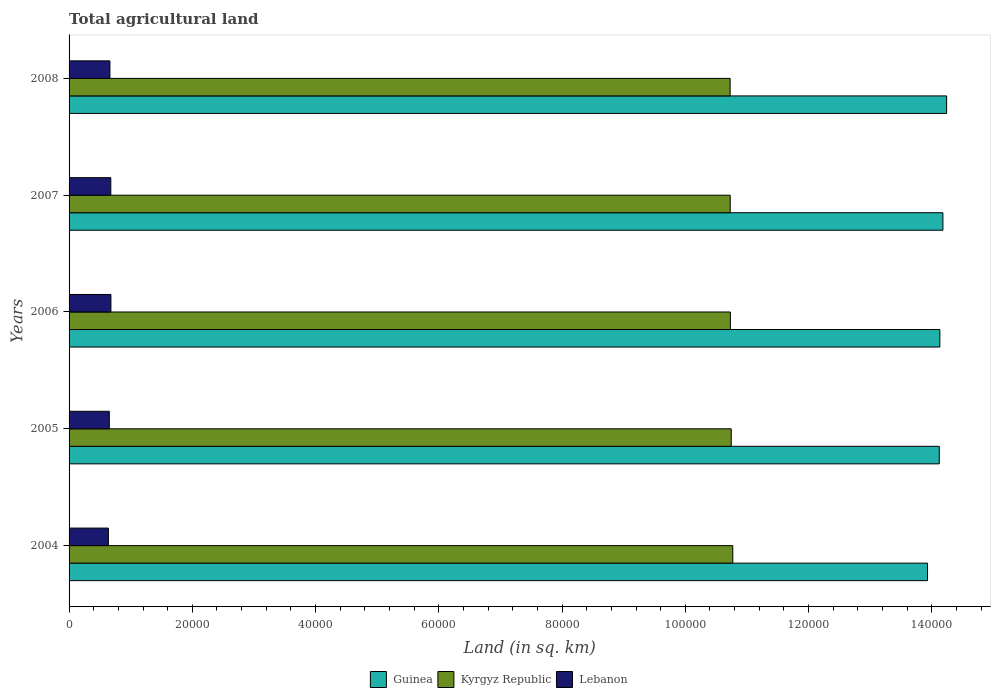How many bars are there on the 3rd tick from the top?
Offer a very short reply. 3. In how many cases, is the number of bars for a given year not equal to the number of legend labels?
Provide a succinct answer. 0. What is the total agricultural land in Lebanon in 2006?
Make the answer very short. 6790. Across all years, what is the maximum total agricultural land in Kyrgyz Republic?
Give a very brief answer. 1.08e+05. Across all years, what is the minimum total agricultural land in Lebanon?
Make the answer very short. 6383. In which year was the total agricultural land in Guinea maximum?
Provide a succinct answer. 2008. In which year was the total agricultural land in Guinea minimum?
Offer a terse response. 2004. What is the total total agricultural land in Guinea in the graph?
Your answer should be very brief. 7.06e+05. What is the difference between the total agricultural land in Lebanon in 2004 and that in 2005?
Offer a very short reply. -147. What is the difference between the total agricultural land in Lebanon in 2004 and the total agricultural land in Kyrgyz Republic in 2006?
Offer a terse response. -1.01e+05. What is the average total agricultural land in Kyrgyz Republic per year?
Your answer should be compact. 1.07e+05. In the year 2005, what is the difference between the total agricultural land in Lebanon and total agricultural land in Guinea?
Provide a succinct answer. -1.35e+05. What is the ratio of the total agricultural land in Guinea in 2005 to that in 2007?
Your answer should be very brief. 1. Is the total agricultural land in Guinea in 2004 less than that in 2006?
Make the answer very short. Yes. Is the difference between the total agricultural land in Lebanon in 2007 and 2008 greater than the difference between the total agricultural land in Guinea in 2007 and 2008?
Offer a terse response. Yes. What is the difference between the highest and the lowest total agricultural land in Kyrgyz Republic?
Your answer should be compact. 428. Is the sum of the total agricultural land in Kyrgyz Republic in 2005 and 2008 greater than the maximum total agricultural land in Guinea across all years?
Offer a terse response. Yes. What does the 1st bar from the top in 2004 represents?
Ensure brevity in your answer.  Lebanon. What does the 1st bar from the bottom in 2008 represents?
Provide a short and direct response. Guinea. How many bars are there?
Your answer should be very brief. 15. How many years are there in the graph?
Ensure brevity in your answer.  5. Are the values on the major ticks of X-axis written in scientific E-notation?
Make the answer very short. No. Does the graph contain any zero values?
Ensure brevity in your answer.  No. Does the graph contain grids?
Offer a terse response. No. Where does the legend appear in the graph?
Provide a succinct answer. Bottom center. What is the title of the graph?
Keep it short and to the point. Total agricultural land. What is the label or title of the X-axis?
Offer a very short reply. Land (in sq. km). What is the label or title of the Y-axis?
Give a very brief answer. Years. What is the Land (in sq. km) in Guinea in 2004?
Your answer should be compact. 1.39e+05. What is the Land (in sq. km) in Kyrgyz Republic in 2004?
Make the answer very short. 1.08e+05. What is the Land (in sq. km) of Lebanon in 2004?
Give a very brief answer. 6383. What is the Land (in sq. km) of Guinea in 2005?
Provide a succinct answer. 1.41e+05. What is the Land (in sq. km) in Kyrgyz Republic in 2005?
Make the answer very short. 1.07e+05. What is the Land (in sq. km) in Lebanon in 2005?
Keep it short and to the point. 6530. What is the Land (in sq. km) in Guinea in 2006?
Offer a terse response. 1.41e+05. What is the Land (in sq. km) in Kyrgyz Republic in 2006?
Offer a very short reply. 1.07e+05. What is the Land (in sq. km) in Lebanon in 2006?
Your answer should be compact. 6790. What is the Land (in sq. km) in Guinea in 2007?
Offer a terse response. 1.42e+05. What is the Land (in sq. km) of Kyrgyz Republic in 2007?
Provide a succinct answer. 1.07e+05. What is the Land (in sq. km) of Lebanon in 2007?
Offer a terse response. 6771. What is the Land (in sq. km) of Guinea in 2008?
Make the answer very short. 1.42e+05. What is the Land (in sq. km) in Kyrgyz Republic in 2008?
Provide a succinct answer. 1.07e+05. What is the Land (in sq. km) in Lebanon in 2008?
Ensure brevity in your answer.  6630. Across all years, what is the maximum Land (in sq. km) in Guinea?
Make the answer very short. 1.42e+05. Across all years, what is the maximum Land (in sq. km) in Kyrgyz Republic?
Provide a short and direct response. 1.08e+05. Across all years, what is the maximum Land (in sq. km) in Lebanon?
Offer a very short reply. 6790. Across all years, what is the minimum Land (in sq. km) of Guinea?
Keep it short and to the point. 1.39e+05. Across all years, what is the minimum Land (in sq. km) of Kyrgyz Republic?
Your answer should be very brief. 1.07e+05. Across all years, what is the minimum Land (in sq. km) in Lebanon?
Keep it short and to the point. 6383. What is the total Land (in sq. km) in Guinea in the graph?
Provide a short and direct response. 7.06e+05. What is the total Land (in sq. km) of Kyrgyz Republic in the graph?
Offer a terse response. 5.37e+05. What is the total Land (in sq. km) of Lebanon in the graph?
Your answer should be very brief. 3.31e+04. What is the difference between the Land (in sq. km) in Guinea in 2004 and that in 2005?
Provide a short and direct response. -1910. What is the difference between the Land (in sq. km) of Kyrgyz Republic in 2004 and that in 2005?
Give a very brief answer. 250. What is the difference between the Land (in sq. km) in Lebanon in 2004 and that in 2005?
Your answer should be very brief. -147. What is the difference between the Land (in sq. km) of Guinea in 2004 and that in 2006?
Your answer should be very brief. -2000. What is the difference between the Land (in sq. km) of Kyrgyz Republic in 2004 and that in 2006?
Give a very brief answer. 389. What is the difference between the Land (in sq. km) of Lebanon in 2004 and that in 2006?
Your response must be concise. -407. What is the difference between the Land (in sq. km) of Guinea in 2004 and that in 2007?
Your answer should be very brief. -2500. What is the difference between the Land (in sq. km) of Kyrgyz Republic in 2004 and that in 2007?
Ensure brevity in your answer.  414. What is the difference between the Land (in sq. km) of Lebanon in 2004 and that in 2007?
Your answer should be very brief. -388. What is the difference between the Land (in sq. km) in Guinea in 2004 and that in 2008?
Make the answer very short. -3100. What is the difference between the Land (in sq. km) of Kyrgyz Republic in 2004 and that in 2008?
Provide a succinct answer. 428. What is the difference between the Land (in sq. km) in Lebanon in 2004 and that in 2008?
Make the answer very short. -247. What is the difference between the Land (in sq. km) of Guinea in 2005 and that in 2006?
Your response must be concise. -90. What is the difference between the Land (in sq. km) in Kyrgyz Republic in 2005 and that in 2006?
Offer a very short reply. 139. What is the difference between the Land (in sq. km) in Lebanon in 2005 and that in 2006?
Make the answer very short. -260. What is the difference between the Land (in sq. km) of Guinea in 2005 and that in 2007?
Provide a short and direct response. -590. What is the difference between the Land (in sq. km) in Kyrgyz Republic in 2005 and that in 2007?
Your answer should be very brief. 164. What is the difference between the Land (in sq. km) in Lebanon in 2005 and that in 2007?
Your response must be concise. -241. What is the difference between the Land (in sq. km) of Guinea in 2005 and that in 2008?
Make the answer very short. -1190. What is the difference between the Land (in sq. km) of Kyrgyz Republic in 2005 and that in 2008?
Give a very brief answer. 178. What is the difference between the Land (in sq. km) in Lebanon in 2005 and that in 2008?
Keep it short and to the point. -100. What is the difference between the Land (in sq. km) in Guinea in 2006 and that in 2007?
Your response must be concise. -500. What is the difference between the Land (in sq. km) of Guinea in 2006 and that in 2008?
Make the answer very short. -1100. What is the difference between the Land (in sq. km) in Kyrgyz Republic in 2006 and that in 2008?
Offer a very short reply. 39. What is the difference between the Land (in sq. km) of Lebanon in 2006 and that in 2008?
Ensure brevity in your answer.  160. What is the difference between the Land (in sq. km) of Guinea in 2007 and that in 2008?
Provide a succinct answer. -600. What is the difference between the Land (in sq. km) of Kyrgyz Republic in 2007 and that in 2008?
Your response must be concise. 14. What is the difference between the Land (in sq. km) in Lebanon in 2007 and that in 2008?
Offer a very short reply. 141. What is the difference between the Land (in sq. km) of Guinea in 2004 and the Land (in sq. km) of Kyrgyz Republic in 2005?
Provide a succinct answer. 3.18e+04. What is the difference between the Land (in sq. km) in Guinea in 2004 and the Land (in sq. km) in Lebanon in 2005?
Your answer should be compact. 1.33e+05. What is the difference between the Land (in sq. km) of Kyrgyz Republic in 2004 and the Land (in sq. km) of Lebanon in 2005?
Offer a terse response. 1.01e+05. What is the difference between the Land (in sq. km) in Guinea in 2004 and the Land (in sq. km) in Kyrgyz Republic in 2006?
Provide a short and direct response. 3.20e+04. What is the difference between the Land (in sq. km) of Guinea in 2004 and the Land (in sq. km) of Lebanon in 2006?
Your response must be concise. 1.33e+05. What is the difference between the Land (in sq. km) in Kyrgyz Republic in 2004 and the Land (in sq. km) in Lebanon in 2006?
Your answer should be very brief. 1.01e+05. What is the difference between the Land (in sq. km) of Guinea in 2004 and the Land (in sq. km) of Kyrgyz Republic in 2007?
Your response must be concise. 3.20e+04. What is the difference between the Land (in sq. km) of Guinea in 2004 and the Land (in sq. km) of Lebanon in 2007?
Offer a very short reply. 1.33e+05. What is the difference between the Land (in sq. km) in Kyrgyz Republic in 2004 and the Land (in sq. km) in Lebanon in 2007?
Offer a terse response. 1.01e+05. What is the difference between the Land (in sq. km) of Guinea in 2004 and the Land (in sq. km) of Kyrgyz Republic in 2008?
Give a very brief answer. 3.20e+04. What is the difference between the Land (in sq. km) in Guinea in 2004 and the Land (in sq. km) in Lebanon in 2008?
Keep it short and to the point. 1.33e+05. What is the difference between the Land (in sq. km) of Kyrgyz Republic in 2004 and the Land (in sq. km) of Lebanon in 2008?
Provide a short and direct response. 1.01e+05. What is the difference between the Land (in sq. km) in Guinea in 2005 and the Land (in sq. km) in Kyrgyz Republic in 2006?
Your answer should be compact. 3.39e+04. What is the difference between the Land (in sq. km) of Guinea in 2005 and the Land (in sq. km) of Lebanon in 2006?
Make the answer very short. 1.34e+05. What is the difference between the Land (in sq. km) of Kyrgyz Republic in 2005 and the Land (in sq. km) of Lebanon in 2006?
Provide a short and direct response. 1.01e+05. What is the difference between the Land (in sq. km) of Guinea in 2005 and the Land (in sq. km) of Kyrgyz Republic in 2007?
Your answer should be very brief. 3.39e+04. What is the difference between the Land (in sq. km) of Guinea in 2005 and the Land (in sq. km) of Lebanon in 2007?
Make the answer very short. 1.34e+05. What is the difference between the Land (in sq. km) of Kyrgyz Republic in 2005 and the Land (in sq. km) of Lebanon in 2007?
Provide a succinct answer. 1.01e+05. What is the difference between the Land (in sq. km) of Guinea in 2005 and the Land (in sq. km) of Kyrgyz Republic in 2008?
Make the answer very short. 3.39e+04. What is the difference between the Land (in sq. km) of Guinea in 2005 and the Land (in sq. km) of Lebanon in 2008?
Keep it short and to the point. 1.35e+05. What is the difference between the Land (in sq. km) of Kyrgyz Republic in 2005 and the Land (in sq. km) of Lebanon in 2008?
Your answer should be very brief. 1.01e+05. What is the difference between the Land (in sq. km) of Guinea in 2006 and the Land (in sq. km) of Kyrgyz Republic in 2007?
Offer a terse response. 3.40e+04. What is the difference between the Land (in sq. km) in Guinea in 2006 and the Land (in sq. km) in Lebanon in 2007?
Your answer should be very brief. 1.35e+05. What is the difference between the Land (in sq. km) in Kyrgyz Republic in 2006 and the Land (in sq. km) in Lebanon in 2007?
Offer a very short reply. 1.01e+05. What is the difference between the Land (in sq. km) in Guinea in 2006 and the Land (in sq. km) in Kyrgyz Republic in 2008?
Give a very brief answer. 3.40e+04. What is the difference between the Land (in sq. km) in Guinea in 2006 and the Land (in sq. km) in Lebanon in 2008?
Ensure brevity in your answer.  1.35e+05. What is the difference between the Land (in sq. km) in Kyrgyz Republic in 2006 and the Land (in sq. km) in Lebanon in 2008?
Ensure brevity in your answer.  1.01e+05. What is the difference between the Land (in sq. km) of Guinea in 2007 and the Land (in sq. km) of Kyrgyz Republic in 2008?
Offer a very short reply. 3.45e+04. What is the difference between the Land (in sq. km) in Guinea in 2007 and the Land (in sq. km) in Lebanon in 2008?
Ensure brevity in your answer.  1.35e+05. What is the difference between the Land (in sq. km) of Kyrgyz Republic in 2007 and the Land (in sq. km) of Lebanon in 2008?
Provide a short and direct response. 1.01e+05. What is the average Land (in sq. km) of Guinea per year?
Provide a short and direct response. 1.41e+05. What is the average Land (in sq. km) of Kyrgyz Republic per year?
Your answer should be very brief. 1.07e+05. What is the average Land (in sq. km) of Lebanon per year?
Make the answer very short. 6620.8. In the year 2004, what is the difference between the Land (in sq. km) in Guinea and Land (in sq. km) in Kyrgyz Republic?
Make the answer very short. 3.16e+04. In the year 2004, what is the difference between the Land (in sq. km) in Guinea and Land (in sq. km) in Lebanon?
Offer a very short reply. 1.33e+05. In the year 2004, what is the difference between the Land (in sq. km) in Kyrgyz Republic and Land (in sq. km) in Lebanon?
Offer a very short reply. 1.01e+05. In the year 2005, what is the difference between the Land (in sq. km) of Guinea and Land (in sq. km) of Kyrgyz Republic?
Your answer should be compact. 3.38e+04. In the year 2005, what is the difference between the Land (in sq. km) of Guinea and Land (in sq. km) of Lebanon?
Your answer should be very brief. 1.35e+05. In the year 2005, what is the difference between the Land (in sq. km) of Kyrgyz Republic and Land (in sq. km) of Lebanon?
Ensure brevity in your answer.  1.01e+05. In the year 2006, what is the difference between the Land (in sq. km) of Guinea and Land (in sq. km) of Kyrgyz Republic?
Ensure brevity in your answer.  3.40e+04. In the year 2006, what is the difference between the Land (in sq. km) of Guinea and Land (in sq. km) of Lebanon?
Offer a terse response. 1.35e+05. In the year 2006, what is the difference between the Land (in sq. km) of Kyrgyz Republic and Land (in sq. km) of Lebanon?
Your answer should be compact. 1.01e+05. In the year 2007, what is the difference between the Land (in sq. km) of Guinea and Land (in sq. km) of Kyrgyz Republic?
Your response must be concise. 3.45e+04. In the year 2007, what is the difference between the Land (in sq. km) of Guinea and Land (in sq. km) of Lebanon?
Keep it short and to the point. 1.35e+05. In the year 2007, what is the difference between the Land (in sq. km) of Kyrgyz Republic and Land (in sq. km) of Lebanon?
Keep it short and to the point. 1.01e+05. In the year 2008, what is the difference between the Land (in sq. km) in Guinea and Land (in sq. km) in Kyrgyz Republic?
Your answer should be very brief. 3.51e+04. In the year 2008, what is the difference between the Land (in sq. km) in Guinea and Land (in sq. km) in Lebanon?
Your response must be concise. 1.36e+05. In the year 2008, what is the difference between the Land (in sq. km) of Kyrgyz Republic and Land (in sq. km) of Lebanon?
Keep it short and to the point. 1.01e+05. What is the ratio of the Land (in sq. km) of Guinea in 2004 to that in 2005?
Make the answer very short. 0.99. What is the ratio of the Land (in sq. km) of Kyrgyz Republic in 2004 to that in 2005?
Make the answer very short. 1. What is the ratio of the Land (in sq. km) of Lebanon in 2004 to that in 2005?
Keep it short and to the point. 0.98. What is the ratio of the Land (in sq. km) of Guinea in 2004 to that in 2006?
Offer a very short reply. 0.99. What is the ratio of the Land (in sq. km) of Lebanon in 2004 to that in 2006?
Ensure brevity in your answer.  0.94. What is the ratio of the Land (in sq. km) in Guinea in 2004 to that in 2007?
Keep it short and to the point. 0.98. What is the ratio of the Land (in sq. km) in Kyrgyz Republic in 2004 to that in 2007?
Your answer should be compact. 1. What is the ratio of the Land (in sq. km) in Lebanon in 2004 to that in 2007?
Make the answer very short. 0.94. What is the ratio of the Land (in sq. km) in Guinea in 2004 to that in 2008?
Offer a terse response. 0.98. What is the ratio of the Land (in sq. km) in Lebanon in 2004 to that in 2008?
Provide a short and direct response. 0.96. What is the ratio of the Land (in sq. km) of Kyrgyz Republic in 2005 to that in 2006?
Offer a terse response. 1. What is the ratio of the Land (in sq. km) of Lebanon in 2005 to that in 2006?
Ensure brevity in your answer.  0.96. What is the ratio of the Land (in sq. km) of Guinea in 2005 to that in 2007?
Keep it short and to the point. 1. What is the ratio of the Land (in sq. km) of Kyrgyz Republic in 2005 to that in 2007?
Your answer should be very brief. 1. What is the ratio of the Land (in sq. km) in Lebanon in 2005 to that in 2007?
Ensure brevity in your answer.  0.96. What is the ratio of the Land (in sq. km) of Guinea in 2005 to that in 2008?
Ensure brevity in your answer.  0.99. What is the ratio of the Land (in sq. km) in Lebanon in 2005 to that in 2008?
Give a very brief answer. 0.98. What is the ratio of the Land (in sq. km) of Lebanon in 2006 to that in 2007?
Your answer should be very brief. 1. What is the ratio of the Land (in sq. km) in Guinea in 2006 to that in 2008?
Your answer should be very brief. 0.99. What is the ratio of the Land (in sq. km) of Lebanon in 2006 to that in 2008?
Your answer should be very brief. 1.02. What is the ratio of the Land (in sq. km) of Guinea in 2007 to that in 2008?
Provide a short and direct response. 1. What is the ratio of the Land (in sq. km) of Kyrgyz Republic in 2007 to that in 2008?
Ensure brevity in your answer.  1. What is the ratio of the Land (in sq. km) of Lebanon in 2007 to that in 2008?
Provide a succinct answer. 1.02. What is the difference between the highest and the second highest Land (in sq. km) of Guinea?
Your answer should be compact. 600. What is the difference between the highest and the second highest Land (in sq. km) of Kyrgyz Republic?
Provide a succinct answer. 250. What is the difference between the highest and the second highest Land (in sq. km) in Lebanon?
Your answer should be compact. 19. What is the difference between the highest and the lowest Land (in sq. km) in Guinea?
Provide a short and direct response. 3100. What is the difference between the highest and the lowest Land (in sq. km) of Kyrgyz Republic?
Offer a very short reply. 428. What is the difference between the highest and the lowest Land (in sq. km) in Lebanon?
Your response must be concise. 407. 